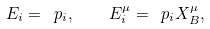<formula> <loc_0><loc_0><loc_500><loc_500>E _ { i } = \ p _ { i } , \quad E _ { i } ^ { \mu } = \ p _ { i } X _ { B } ^ { \mu } ,</formula> 